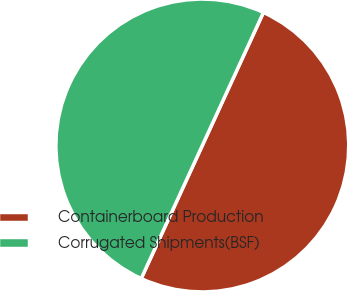Convert chart to OTSL. <chart><loc_0><loc_0><loc_500><loc_500><pie_chart><fcel>Containerboard Production<fcel>Corrugated Shipments(BSF)<nl><fcel>50.0%<fcel>50.0%<nl></chart> 